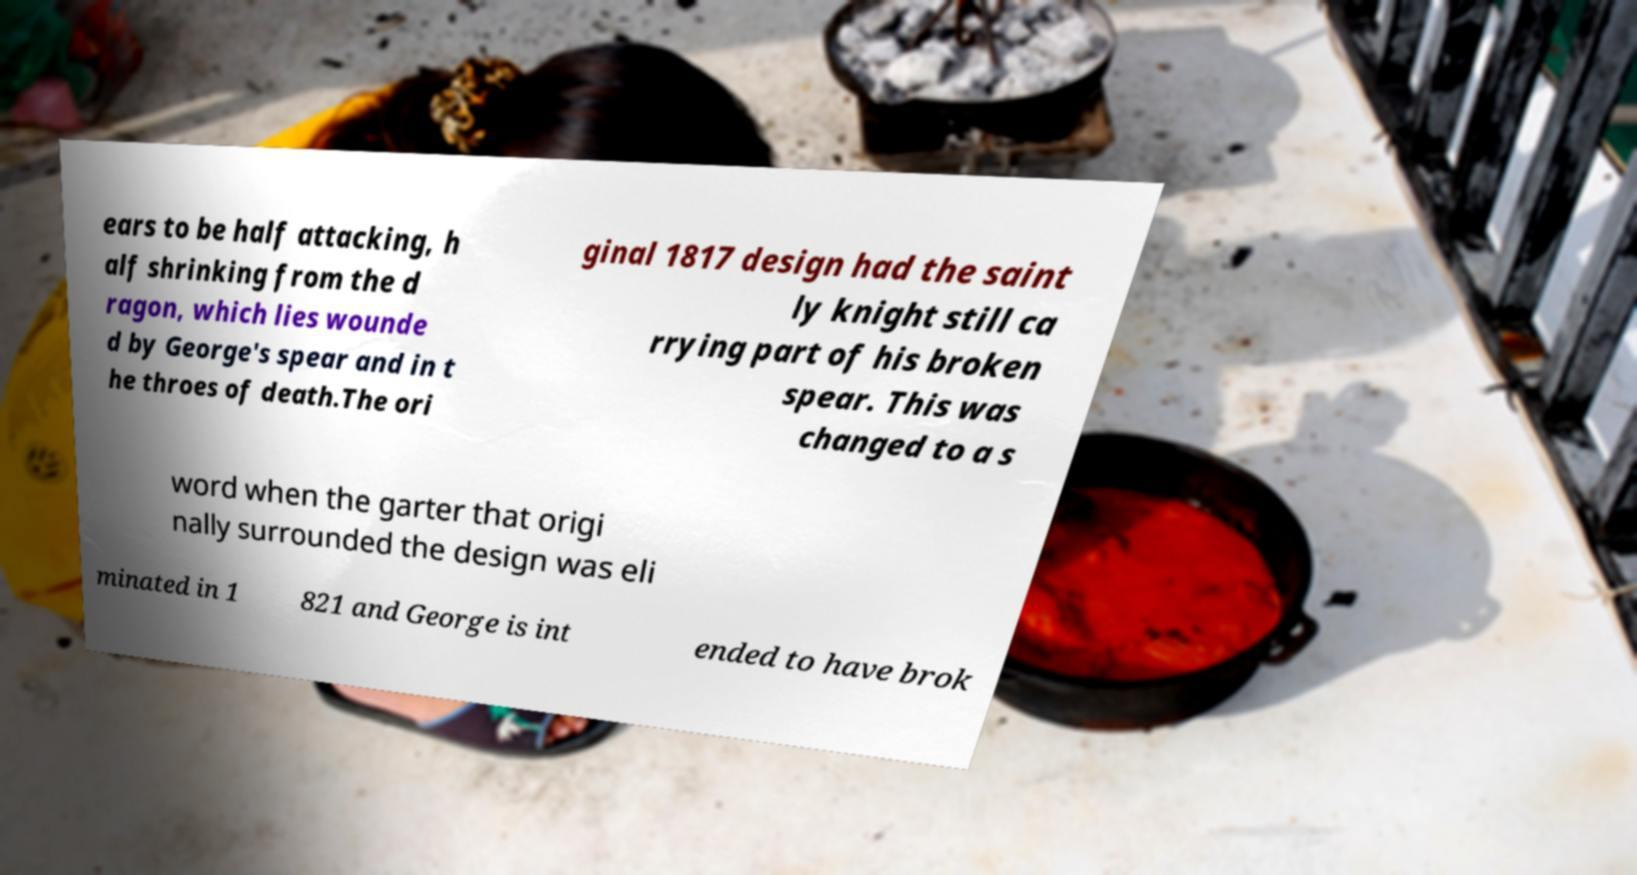Could you assist in decoding the text presented in this image and type it out clearly? ears to be half attacking, h alf shrinking from the d ragon, which lies wounde d by George's spear and in t he throes of death.The ori ginal 1817 design had the saint ly knight still ca rrying part of his broken spear. This was changed to a s word when the garter that origi nally surrounded the design was eli minated in 1 821 and George is int ended to have brok 